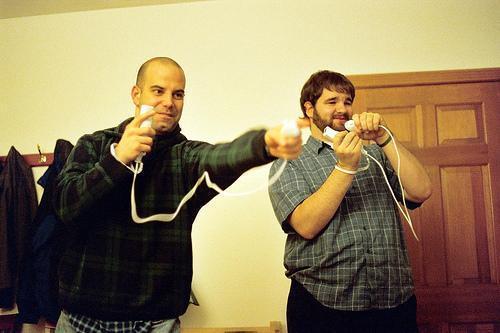How many people are there?
Give a very brief answer. 2. 